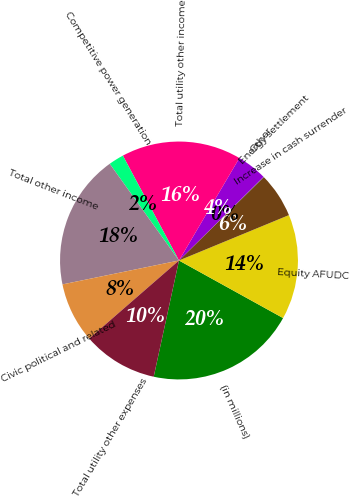Convert chart. <chart><loc_0><loc_0><loc_500><loc_500><pie_chart><fcel>(in millions)<fcel>Equity AFUDC<fcel>Increase in cash surrender<fcel>Energy settlement<fcel>Other<fcel>Total utility other income<fcel>Competitive power generation<fcel>Total other income<fcel>Civic political and related<fcel>Total utility other expenses<nl><fcel>20.37%<fcel>14.27%<fcel>6.14%<fcel>0.04%<fcel>4.11%<fcel>16.3%<fcel>2.07%<fcel>18.33%<fcel>8.17%<fcel>10.2%<nl></chart> 